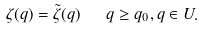<formula> <loc_0><loc_0><loc_500><loc_500>\zeta ( q ) = \tilde { \zeta } ( q ) \ \ q \geq q _ { 0 } , q \in U .</formula> 